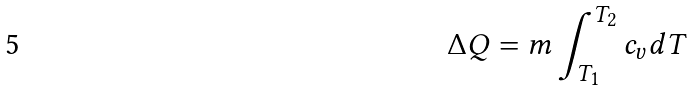Convert formula to latex. <formula><loc_0><loc_0><loc_500><loc_500>\Delta Q = m \int _ { T _ { 1 } } ^ { T _ { 2 } } c _ { v } d T</formula> 